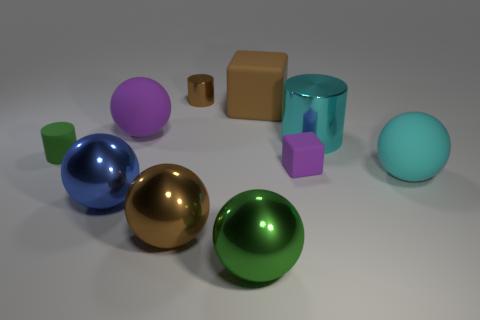Does the purple matte thing behind the big cyan cylinder have the same shape as the green object in front of the small purple object?
Your answer should be compact. Yes. There is a big thing that is the same color as the tiny rubber cylinder; what is its shape?
Keep it short and to the point. Sphere. How many green cylinders are made of the same material as the big cyan ball?
Your answer should be compact. 1. What is the shape of the metallic object that is in front of the green cylinder and on the right side of the brown sphere?
Your answer should be compact. Sphere. Are the brown thing that is to the right of the large green shiny ball and the green cylinder made of the same material?
Offer a terse response. Yes. Are there any other things that have the same material as the green cylinder?
Provide a short and direct response. Yes. There is a matte object that is the same size as the green matte cylinder; what is its color?
Offer a terse response. Purple. Is there a small thing of the same color as the tiny block?
Your answer should be very brief. No. There is a brown ball that is the same material as the blue thing; what is its size?
Provide a short and direct response. Large. The matte object that is the same color as the small shiny thing is what size?
Make the answer very short. Large. 